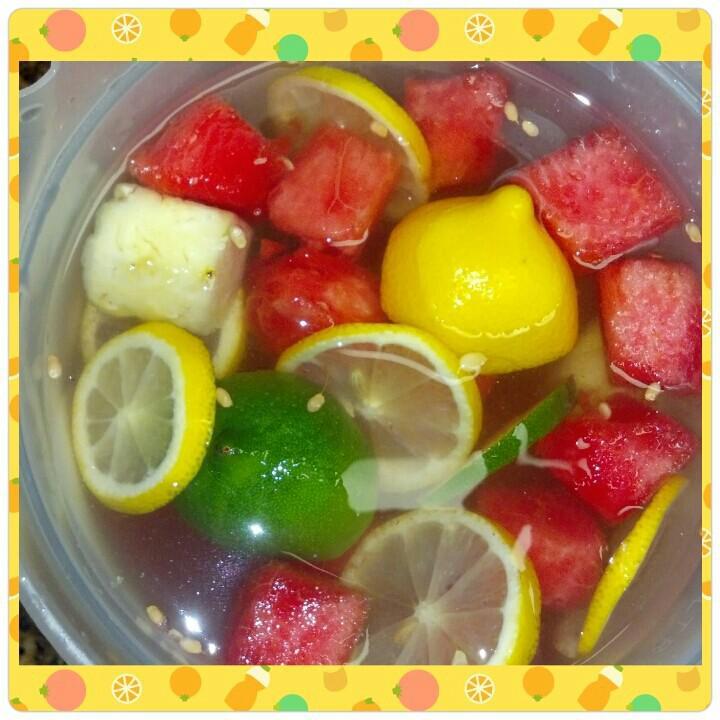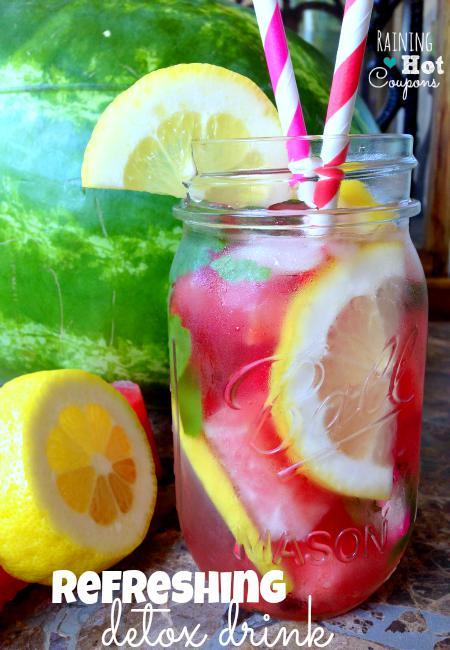The first image is the image on the left, the second image is the image on the right. Analyze the images presented: Is the assertion "In one image, a red drink in a canning jar has at least one straw." valid? Answer yes or no. Yes. The first image is the image on the left, the second image is the image on the right. Considering the images on both sides, is "There is a straw with pink swirl in a drink." valid? Answer yes or no. Yes. 